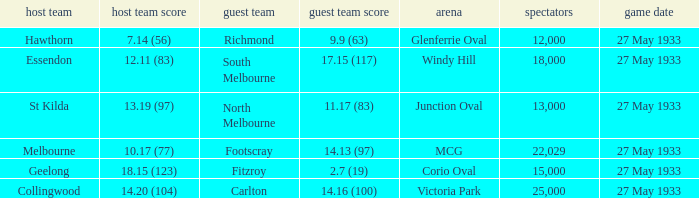Help me parse the entirety of this table. {'header': ['host team', 'host team score', 'guest team', 'guest team score', 'arena', 'spectators', 'game date'], 'rows': [['Hawthorn', '7.14 (56)', 'Richmond', '9.9 (63)', 'Glenferrie Oval', '12,000', '27 May 1933'], ['Essendon', '12.11 (83)', 'South Melbourne', '17.15 (117)', 'Windy Hill', '18,000', '27 May 1933'], ['St Kilda', '13.19 (97)', 'North Melbourne', '11.17 (83)', 'Junction Oval', '13,000', '27 May 1933'], ['Melbourne', '10.17 (77)', 'Footscray', '14.13 (97)', 'MCG', '22,029', '27 May 1933'], ['Geelong', '18.15 (123)', 'Fitzroy', '2.7 (19)', 'Corio Oval', '15,000', '27 May 1933'], ['Collingwood', '14.20 (104)', 'Carlton', '14.16 (100)', 'Victoria Park', '25,000', '27 May 1933']]} In the match where the away team scored 2.7 (19), how many peopel were in the crowd? 15000.0. 